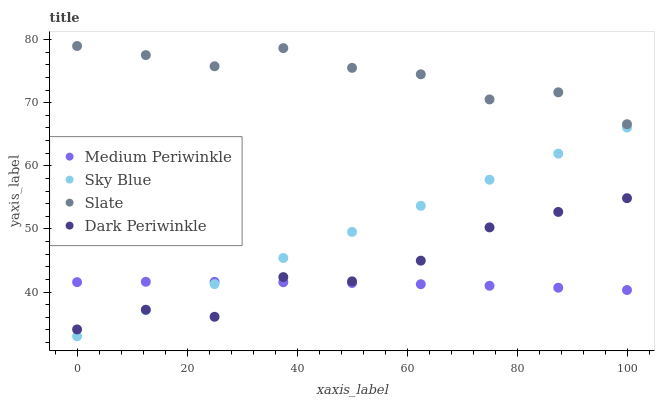Does Medium Periwinkle have the minimum area under the curve?
Answer yes or no. Yes. Does Slate have the maximum area under the curve?
Answer yes or no. Yes. Does Slate have the minimum area under the curve?
Answer yes or no. No. Does Medium Periwinkle have the maximum area under the curve?
Answer yes or no. No. Is Sky Blue the smoothest?
Answer yes or no. Yes. Is Dark Periwinkle the roughest?
Answer yes or no. Yes. Is Slate the smoothest?
Answer yes or no. No. Is Slate the roughest?
Answer yes or no. No. Does Sky Blue have the lowest value?
Answer yes or no. Yes. Does Medium Periwinkle have the lowest value?
Answer yes or no. No. Does Slate have the highest value?
Answer yes or no. Yes. Does Medium Periwinkle have the highest value?
Answer yes or no. No. Is Dark Periwinkle less than Slate?
Answer yes or no. Yes. Is Slate greater than Sky Blue?
Answer yes or no. Yes. Does Dark Periwinkle intersect Sky Blue?
Answer yes or no. Yes. Is Dark Periwinkle less than Sky Blue?
Answer yes or no. No. Is Dark Periwinkle greater than Sky Blue?
Answer yes or no. No. Does Dark Periwinkle intersect Slate?
Answer yes or no. No. 